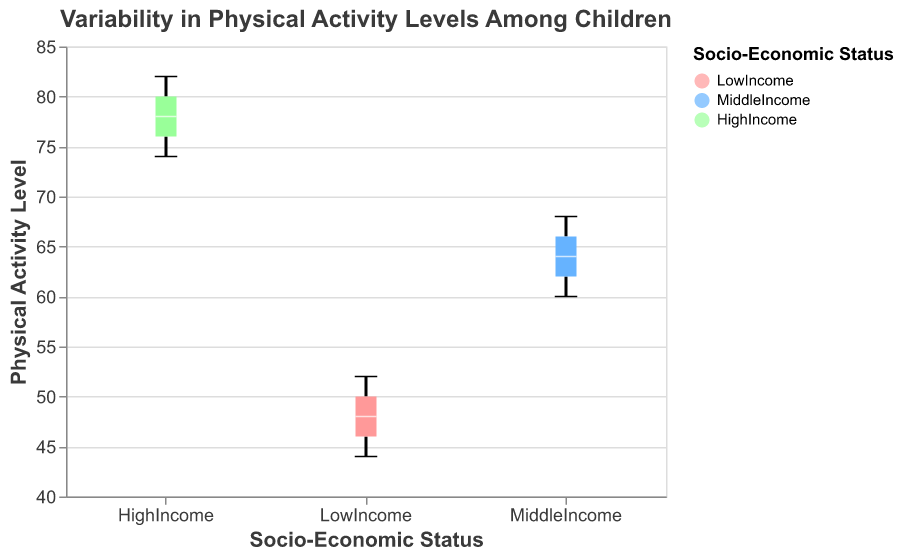What is the title of the plot? The title of the plot is shown at the top and reads "Variability in Physical Activity Levels Among Children."
Answer: Variability in Physical Activity Levels Among Children What is the range of physical activity levels for the Middle Income group? The boxplot shows the lowest and highest values. For Middle Income, it ranges from 60 to 68.
Answer: 60 to 68 What is the median physical activity level for the High Income group? The median is marked by a white line within the box of the High Income group. The median is 78.
Answer: 78 Which socio-economic group has the highest median physical activity level? Compare the median lines in the boxplots for all groups. High Income has the highest median at 78.
Answer: High Income What is the interquartile range (IQR) for the Low Income group? The IQR is the length of the box in the boxplot. For Low Income, it ranges from 46 to 50, so the IQR is 50 - 46 = 4.
Answer: 4 Which socio-economic group shows the highest variability in physical activity levels? The variability is indicated by the range of the whiskers in the boxplot. High Income has the widest range from 74 to 82.
Answer: High Income Is there an overlap in the physical activity levels between Middle Income and High Income groups? The boxplot notches indicate the confidence interval around the median. Since there is no overlap between the notches of Middle Income (60-68) and High Income (74-82), there is no overlap in their physical activity levels.
Answer: No Which group has the lowest physical activity level, and what is that level? The minimum value in the whiskers represents the lowest level for each group. Low Income has the lowest at 44.
Answer: Low Income, 44 Are there any outliers in any of the socio-economic groups' physical activity levels? Outliers are not explicitly marked in the provided boxplots, but none of the whiskers are unusually long to suggest outliers.
Answer: No What is the difference in the median physical activity level between Low Income and Middle Income groups? The Low Income median is 48, and the Middle Income median is 64. The difference is 64 - 48 = 16.
Answer: 16 